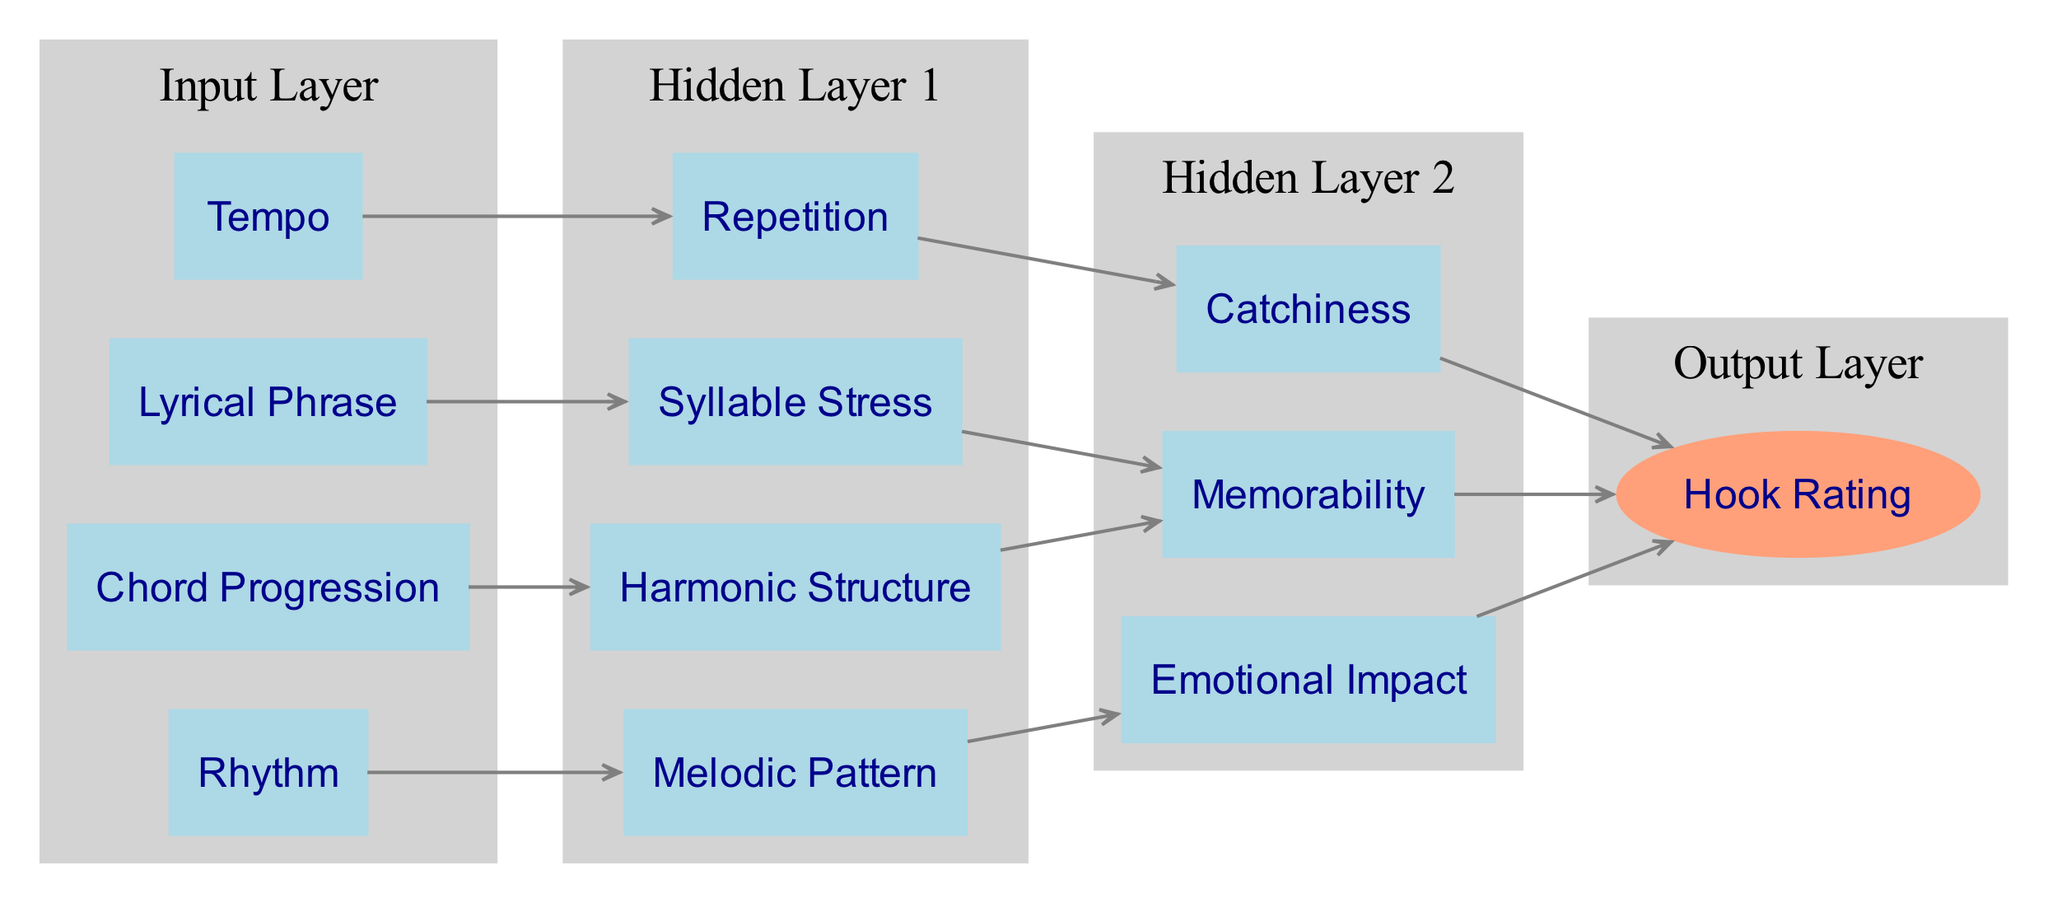What elements are in the input layer? The input layer consists of Rhythm, Chord Progression, Lyrical Phrase, and Tempo. These elements are directly listed under the input layer section of the diagram.
Answer: Rhythm, Chord Progression, Lyrical Phrase, Tempo How many nodes are in the hidden layers? The first hidden layer has 4 nodes (Melodic Pattern, Harmonic Structure, Repetition, Syllable Stress) and the second hidden layer has 3 nodes (Emotional Impact, Memorability, Catchiness), totaling 7 nodes.
Answer: 7 Which element connects to Catchiness? Repetition connects to Catchiness. This is shown graphically in the diagram where an arrow points from Repetition to Catchiness.
Answer: Repetition What is the final output of the neural network? The final output of the neural network is Hook Rating. This is represented as the single node in the output layer section of the diagram, depicted in an ellipse shape.
Answer: Hook Rating How many connections are there from the input layer to the hidden layer 1? There are 4 connections from the input layer to hidden layer 1. Each input node (Rhythm, Chord Progression, Lyrical Phrase, Tempo) connects to one corresponding node in hidden layer 1.
Answer: 4 Which element leads to Emotional Impact? Melodic Pattern leads to Emotional Impact. This relationship is shown by a directed connection (arrow) pointing from Melodic Pattern to Emotional Impact in the diagram.
Answer: Melodic Pattern What is the relationship between Harmonic Structure and Memorability? Harmonic Structure connects to Memorability, indicating that the output of Harmonic Structure contributes to Memorability in the overall model. This is illustrated by an arrow from Harmonic Structure to Memorability.
Answer: Harmonic Structure Which elements influence the Hook Rating? Emotional Impact, Memorability, and Catchiness influence the Hook Rating. These three elements have direct connections (arrows) pointing to the Hook Rating node in the output layer.
Answer: Emotional Impact, Memorability, Catchiness 